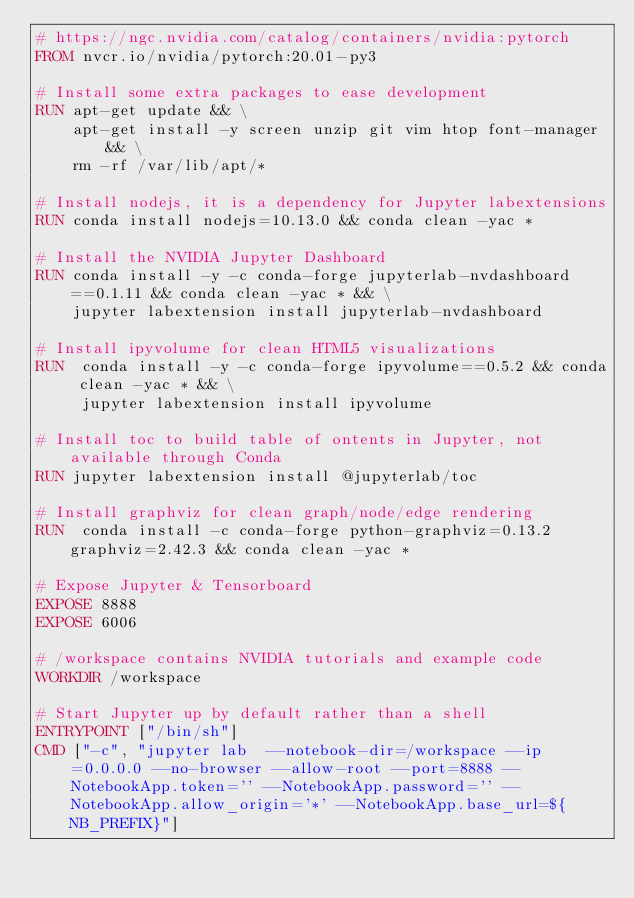Convert code to text. <code><loc_0><loc_0><loc_500><loc_500><_Dockerfile_># https://ngc.nvidia.com/catalog/containers/nvidia:pytorch
FROM nvcr.io/nvidia/pytorch:20.01-py3

# Install some extra packages to ease development
RUN apt-get update && \
    apt-get install -y screen unzip git vim htop font-manager && \
    rm -rf /var/lib/apt/*

# Install nodejs, it is a dependency for Jupyter labextensions
RUN conda install nodejs=10.13.0 && conda clean -yac *

# Install the NVIDIA Jupyter Dashboard
RUN conda install -y -c conda-forge jupyterlab-nvdashboard==0.1.11 && conda clean -yac * && \
    jupyter labextension install jupyterlab-nvdashboard

# Install ipyvolume for clean HTML5 visualizations
RUN  conda install -y -c conda-forge ipyvolume==0.5.2 && conda clean -yac * && \
     jupyter labextension install ipyvolume

# Install toc to build table of ontents in Jupyter, not available through Conda
RUN jupyter labextension install @jupyterlab/toc

# Install graphviz for clean graph/node/edge rendering
RUN  conda install -c conda-forge python-graphviz=0.13.2 graphviz=2.42.3 && conda clean -yac *

# Expose Jupyter & Tensorboard
EXPOSE 8888
EXPOSE 6006

# /workspace contains NVIDIA tutorials and example code
WORKDIR /workspace

# Start Jupyter up by default rather than a shell
ENTRYPOINT ["/bin/sh"]
CMD ["-c", "jupyter lab  --notebook-dir=/workspace --ip=0.0.0.0 --no-browser --allow-root --port=8888 --NotebookApp.token='' --NotebookApp.password='' --NotebookApp.allow_origin='*' --NotebookApp.base_url=${NB_PREFIX}"]
</code> 